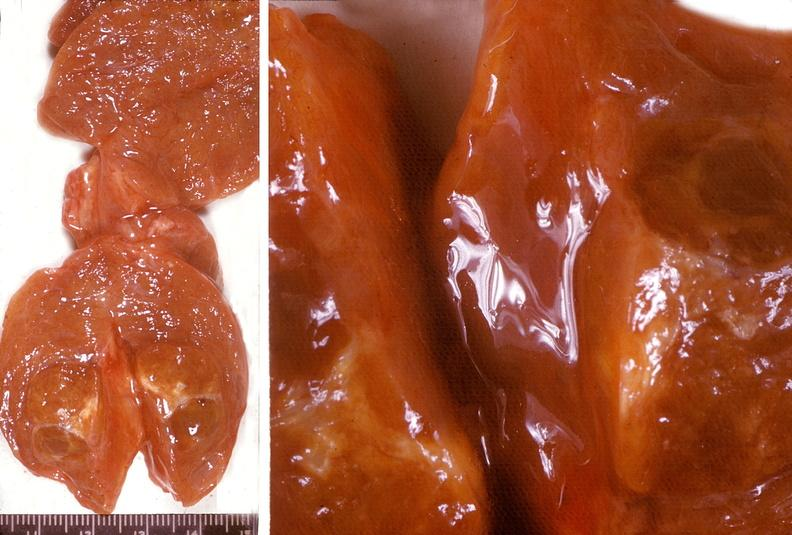what does this image show?
Answer the question using a single word or phrase. Thyroid 